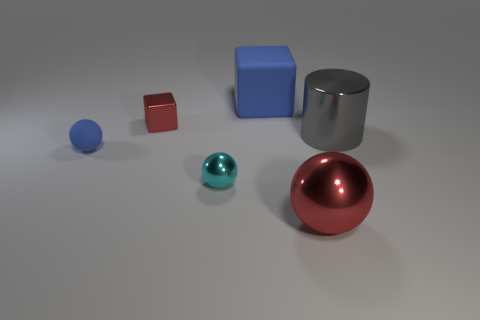Add 2 small cyan metallic objects. How many objects exist? 8 Subtract all cylinders. How many objects are left? 5 Subtract all large red metal spheres. Subtract all gray shiny things. How many objects are left? 4 Add 4 metallic balls. How many metallic balls are left? 6 Add 1 large blue matte cubes. How many large blue matte cubes exist? 2 Subtract 0 gray cubes. How many objects are left? 6 